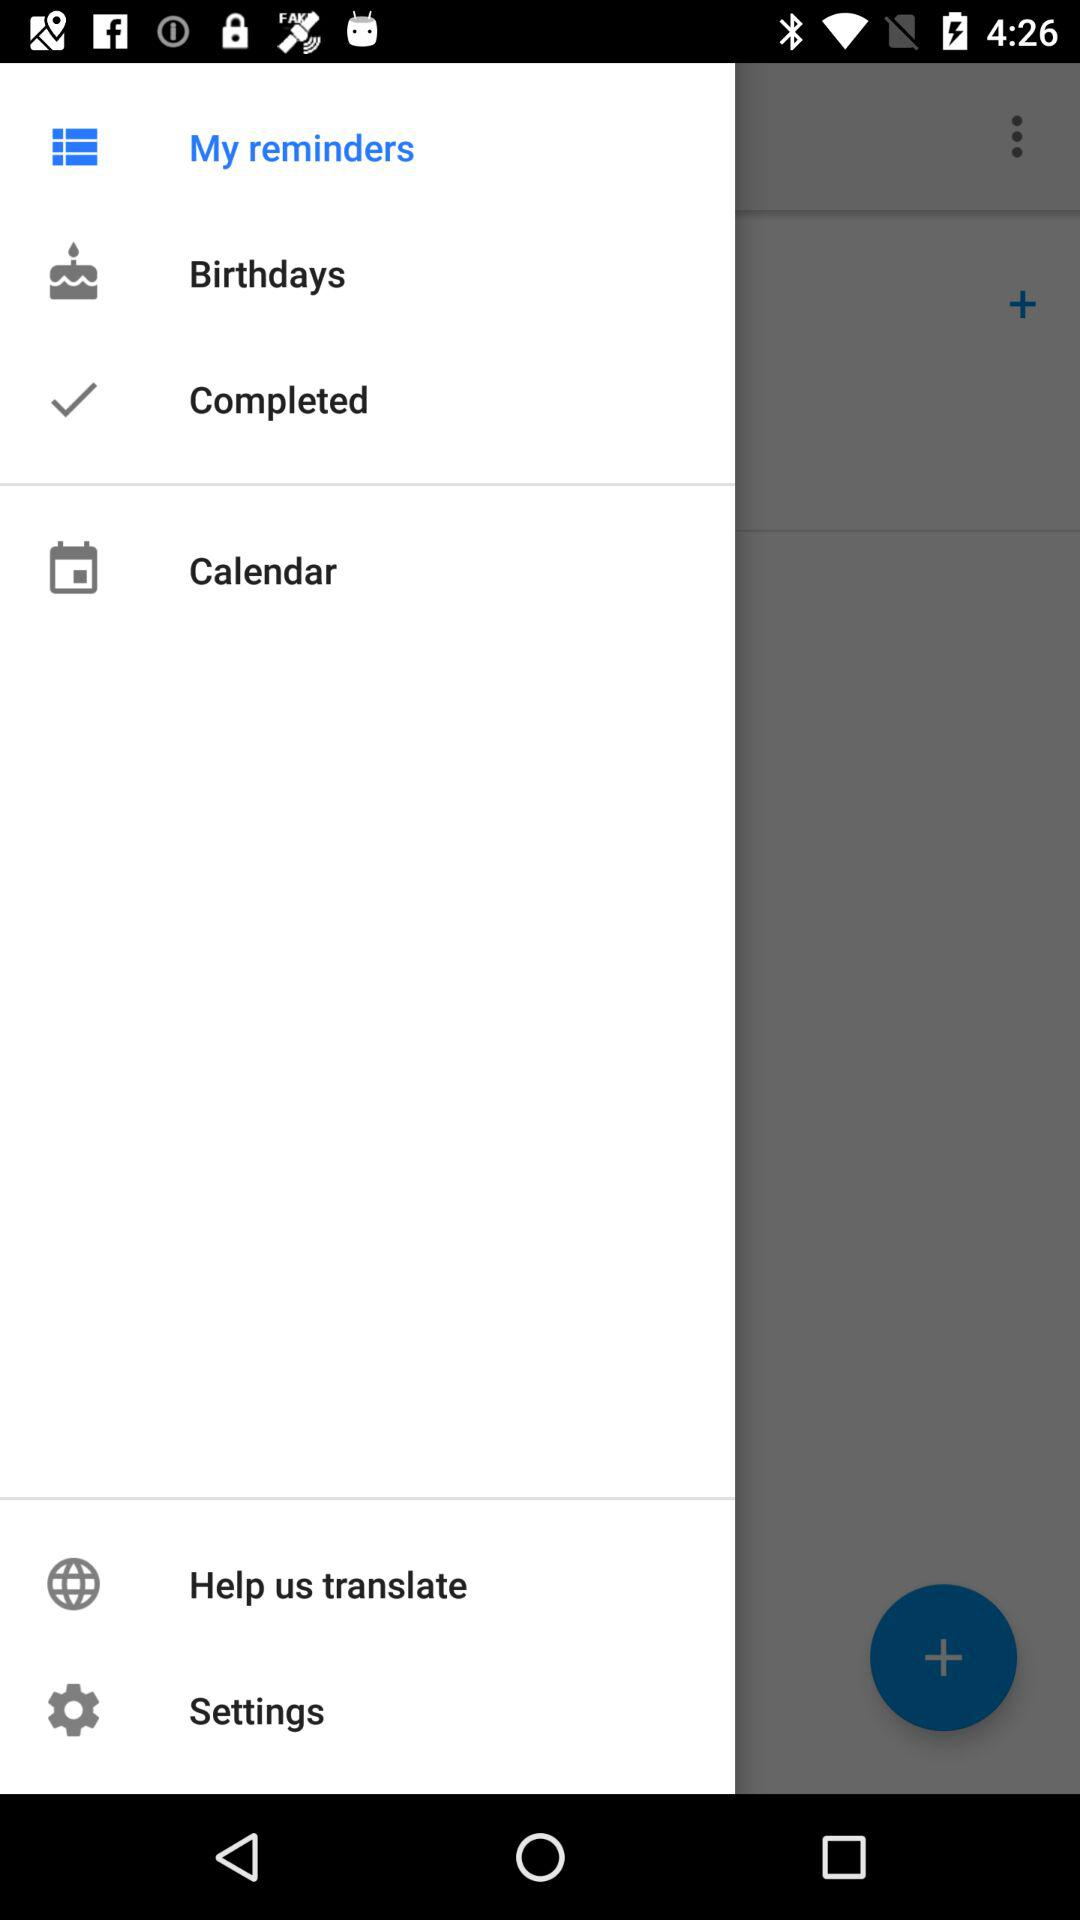How many items have a checkmark?
Answer the question using a single word or phrase. 1 